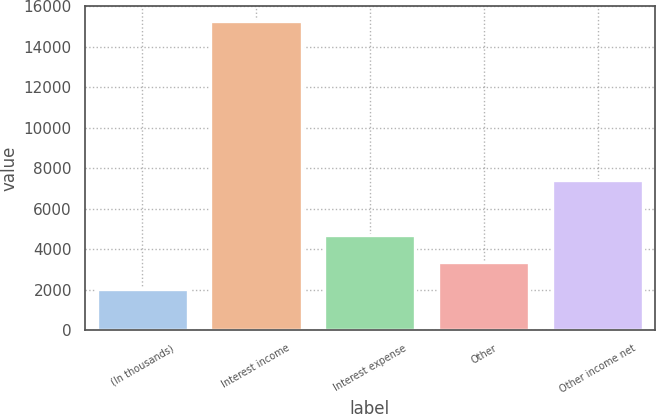<chart> <loc_0><loc_0><loc_500><loc_500><bar_chart><fcel>(In thousands)<fcel>Interest income<fcel>Interest expense<fcel>Other<fcel>Other income net<nl><fcel>2016<fcel>15252<fcel>4675.6<fcel>3352<fcel>7421<nl></chart> 